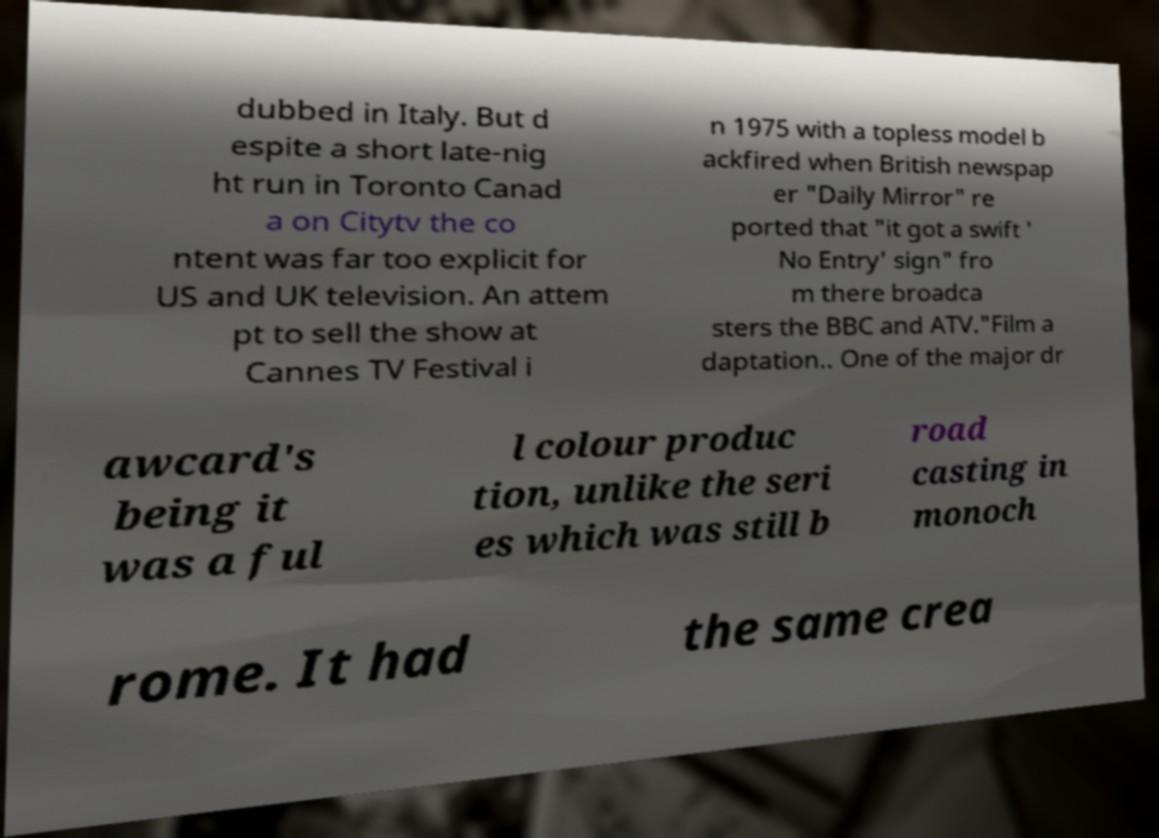Could you extract and type out the text from this image? dubbed in Italy. But d espite a short late-nig ht run in Toronto Canad a on Citytv the co ntent was far too explicit for US and UK television. An attem pt to sell the show at Cannes TV Festival i n 1975 with a topless model b ackfired when British newspap er "Daily Mirror" re ported that "it got a swift ' No Entry' sign" fro m there broadca sters the BBC and ATV."Film a daptation.. One of the major dr awcard's being it was a ful l colour produc tion, unlike the seri es which was still b road casting in monoch rome. It had the same crea 